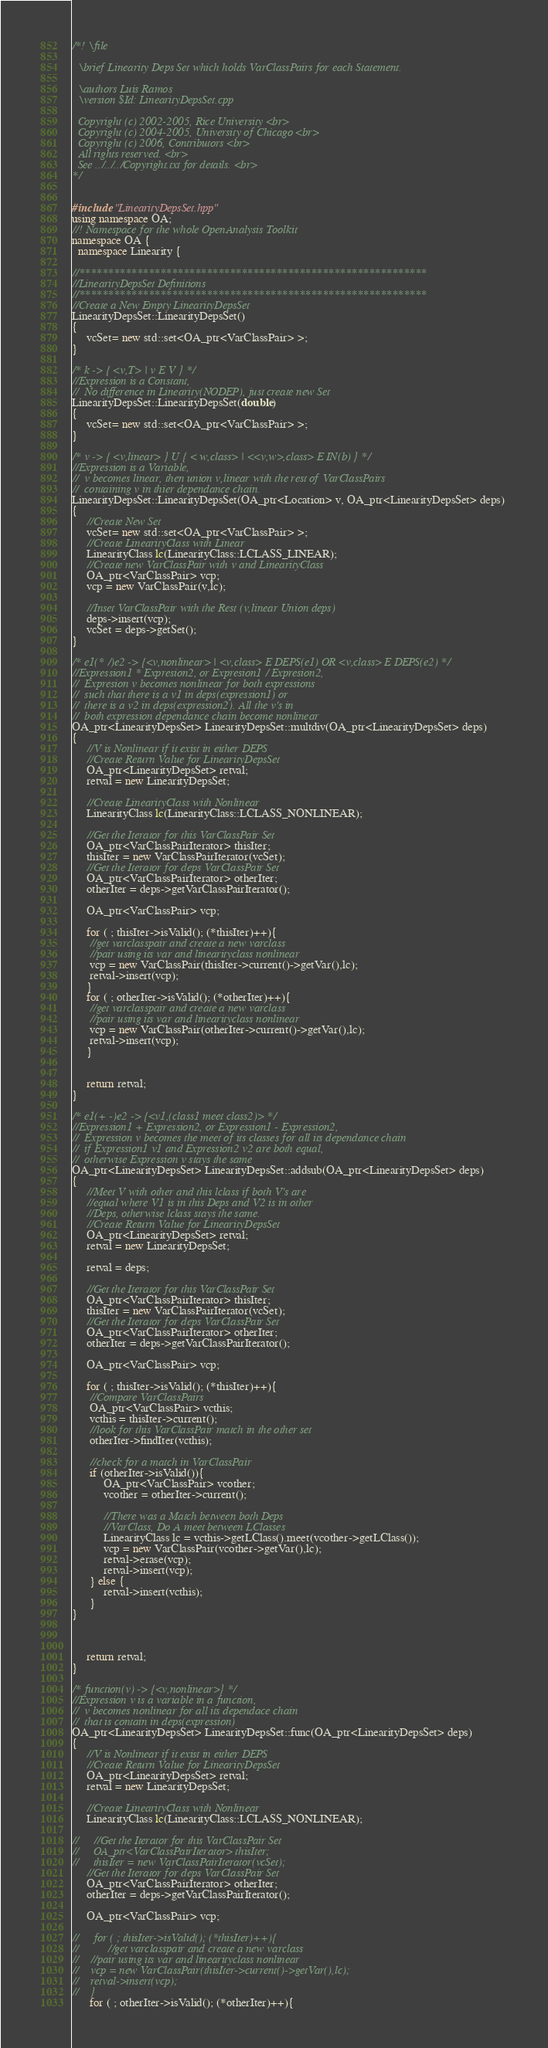<code> <loc_0><loc_0><loc_500><loc_500><_C++_>/*! \file
  
  \brief Linearity Deps Set which holds VarClassPairs for each Statement.

  \authors Luis Ramos
  \version $Id: LinearityDepsSet.cpp

  Copyright (c) 2002-2005, Rice University <br>
  Copyright (c) 2004-2005, University of Chicago <br>
  Copyright (c) 2006, Contributors <br>
  All rights reserved. <br>
  See ../../../Copyright.txt for details. <br>
*/


#include "LinearityDepsSet.hpp"
using namespace OA;
//! Namespace for the whole OpenAnalysis Toolkit
namespace OA {
  namespace Linearity {

//************************************************************
//LinearityDepsSet Definitions
//************************************************************
//Create a New Empty LinearityDepsSet
LinearityDepsSet::LinearityDepsSet() 
{
     vcSet= new std::set<OA_ptr<VarClassPair> >; 
}

/* k -> { <v,T> | v E V } */
//Expression is a Constant, 
//  No difference in Linearity(NODEP), just create new Set
LinearityDepsSet::LinearityDepsSet(double) 
{
     vcSet= new std::set<OA_ptr<VarClassPair> >;
}

/* v -> { <v,linear> } U { < w,class> | <<v,w>,class> E IN(b) } */
//Expression is a Variable,
//  v becomes linear, then union v,linear with the rest of VarClassPairs
//  containing v in thier dependance chain.
LinearityDepsSet::LinearityDepsSet(OA_ptr<Location> v, OA_ptr<LinearityDepsSet> deps) 
{
     //Create New Set
     vcSet= new std::set<OA_ptr<VarClassPair> >;
     //Create LinearityClass with Linear
     LinearityClass lc(LinearityClass::LCLASS_LINEAR);
     //Create new VarClassPair with v and LinearityClass
     OA_ptr<VarClassPair> vcp;
     vcp = new VarClassPair(v,lc);

     //Inset VarClassPair with the Rest (v,linear Union deps)
     deps->insert(vcp);
     vcSet = deps->getSet();
}

/* e1(* /)e2 -> {<v,nonlinear> | <v,class> E DEPS(e1) OR <v,class> E DEPS(e2) */
//Expression1 * Expresion2, or Expresion1 / Expresion2,
//  Expresion v becomes nonlinear for both expressions
//  such that there is a v1 in deps(expression1) or
//  there is a v2 in deps(expression2). All the v's in
//  both expression dependance chain become nonlinear
OA_ptr<LinearityDepsSet> LinearityDepsSet::multdiv(OA_ptr<LinearityDepsSet> deps) 
{
     //V is Nonlinear if it exist in either DEPS
     //Create Return Value for LinearityDepsSet
     OA_ptr<LinearityDepsSet> retval;
     retval = new LinearityDepsSet;

     //Create LinearityClass with Nonlinear
     LinearityClass lc(LinearityClass::LCLASS_NONLINEAR);

     //Get the Iterator for this VarClassPair Set
     OA_ptr<VarClassPairIterator> thisIter; 
     thisIter = new VarClassPairIterator(vcSet);
     //Get the Iterator for deps VarClassPair Set
     OA_ptr<VarClassPairIterator> otherIter;
     otherIter = deps->getVarClassPairIterator();

     OA_ptr<VarClassPair> vcp;

     for ( ; thisIter->isValid(); (*thisIter)++){
      //get varclasspair and create a new varclass
      //pair using its var and linearityclass nonlinear
      vcp = new VarClassPair(thisIter->current()->getVar(),lc);
      retval->insert(vcp);
     }
     for ( ; otherIter->isValid(); (*otherIter)++){
      //get varclasspair and create a new varclass
	  //pair using its var and linearityclass nonlinear
      vcp = new VarClassPair(otherIter->current()->getVar(),lc);
      retval->insert(vcp);
     }


     return retval;
}

/* e1(+ -)e2 -> {<v1,(class1 meet class2)> */
//Expression1 + Expression2, or Expression1 - Expression2,
//  Expression v becomes the meet of its classes for all its dependance chain
//  if Expression1 v1 and Expression2 v2 are both equal,
//  otherwise Expression v stays the same
OA_ptr<LinearityDepsSet> LinearityDepsSet::addsub(OA_ptr<LinearityDepsSet> deps) 
{
     //Meet V with other and this lclass if both V's are
     //equal where V1 is in this Deps and V2 is in other
     //Deps, otherwise lclass stays the same.
     //Create Return Value for LinearityDepsSet
     OA_ptr<LinearityDepsSet> retval;
     retval = new LinearityDepsSet;
     
     retval = deps;

     //Get the Iterator for this VarClassPair Set
     OA_ptr<VarClassPairIterator> thisIter; 
     thisIter = new VarClassPairIterator(vcSet);
     //Get the Iterator for deps VarClassPair Set
     OA_ptr<VarClassPairIterator> otherIter;
     otherIter = deps->getVarClassPairIterator();

     OA_ptr<VarClassPair> vcp;

     for ( ; thisIter->isValid(); (*thisIter)++){
      //Compare VarClassPairs
      OA_ptr<VarClassPair> vcthis;
      vcthis = thisIter->current();
      //look for this VarClassPair match in the other set
      otherIter->findIter(vcthis);

      //check for a match in VarClassPair
      if (otherIter->isValid()){
           OA_ptr<VarClassPair> vcother;
           vcother = otherIter->current();
	       
           //There was a Match between both Deps
           //VarClass, Do A meet between LClasses
           LinearityClass lc = vcthis->getLClass().meet(vcother->getLClass());
           vcp = new VarClassPair(vcother->getVar(),lc);
           retval->erase(vcp);
           retval->insert(vcp);
      } else {
           retval->insert(vcthis);
      }
}



     return retval;
}

/* function(v) -> {<v,nonlinear>} */
//Expression v is a variable in a function,
//  v becomes nonlinear for all its dependace chain
//  that is contain in deps(expression)
OA_ptr<LinearityDepsSet> LinearityDepsSet::func(OA_ptr<LinearityDepsSet> deps) 
{
     //V is Nonlinear if it exist in either DEPS
     //Create Return Value for LinearityDepsSet
     OA_ptr<LinearityDepsSet> retval;
     retval = new LinearityDepsSet;

     //Create LinearityClass with Nonlinear
     LinearityClass lc(LinearityClass::LCLASS_NONLINEAR);

//     //Get the Iterator for this VarClassPair Set
//     OA_ptr<VarClassPairIterator> thisIter; 
//     thisIter = new VarClassPairIterator(vcSet);
     //Get the Iterator for deps VarClassPair Set
     OA_ptr<VarClassPairIterator> otherIter;
     otherIter = deps->getVarClassPairIterator();

     OA_ptr<VarClassPair> vcp;

//     for ( ; thisIter->isValid(); (*thisIter)++){
//          //get varclasspair and create a new varclass
//	  //pair using its var and linearityclass nonlinear
//	  vcp = new VarClassPair(thisIter->current()->getVar(),lc);
//	  retval->insert(vcp);
//    }
      for ( ; otherIter->isValid(); (*otherIter)++){</code> 